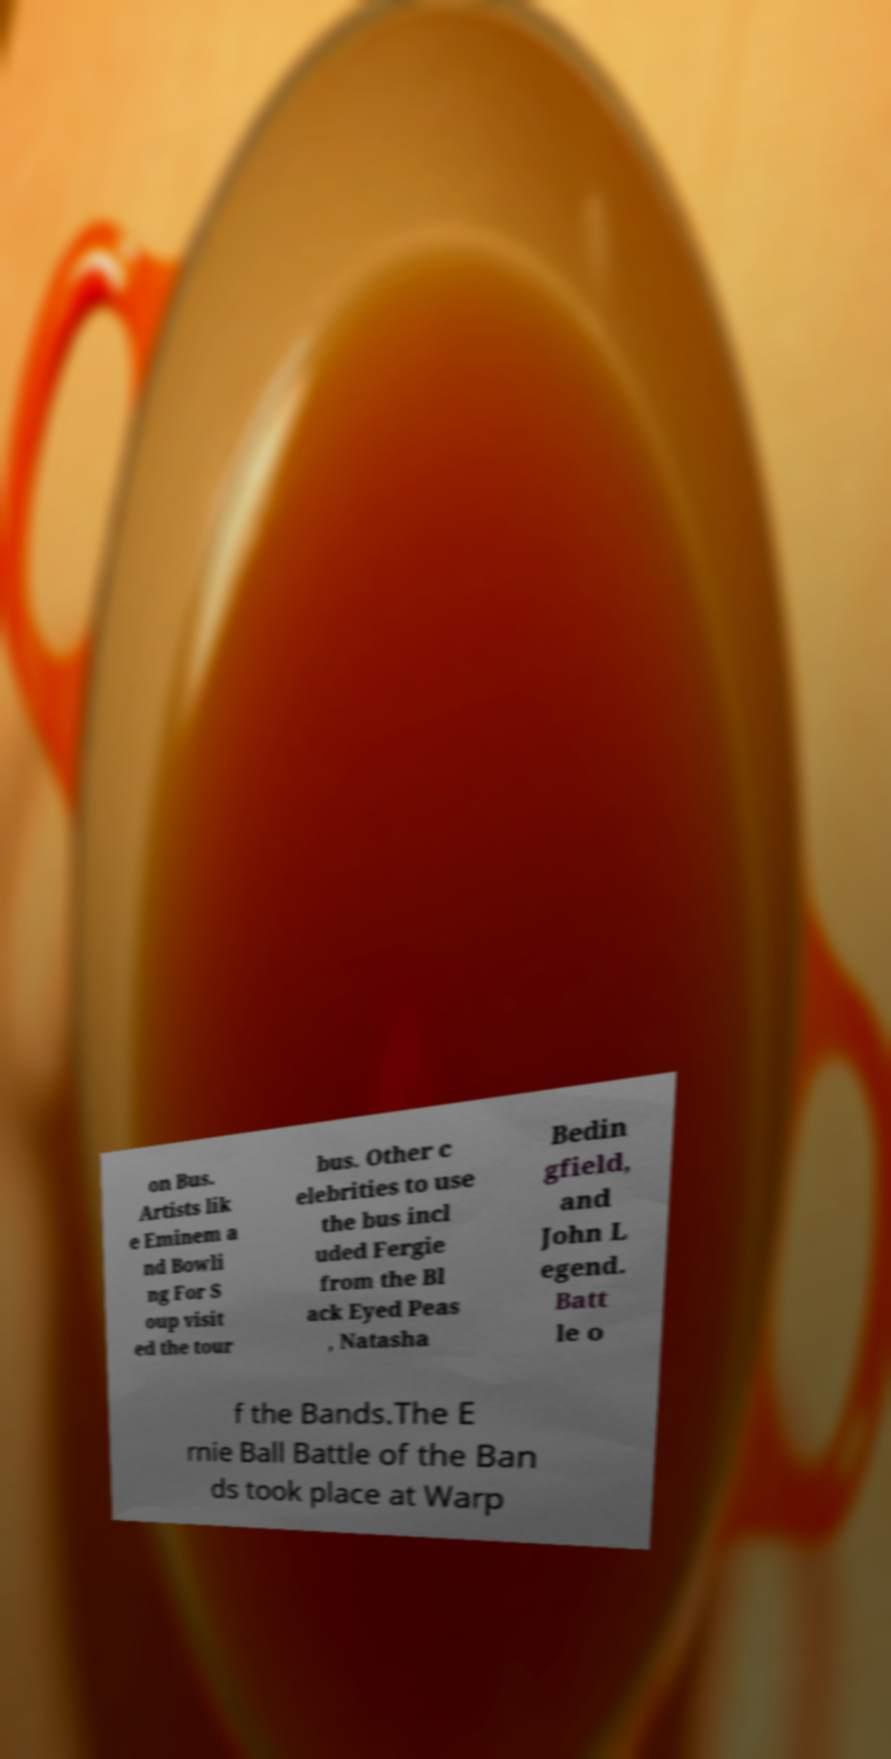Could you assist in decoding the text presented in this image and type it out clearly? on Bus. Artists lik e Eminem a nd Bowli ng For S oup visit ed the tour bus. Other c elebrities to use the bus incl uded Fergie from the Bl ack Eyed Peas , Natasha Bedin gfield, and John L egend. Batt le o f the Bands.The E rnie Ball Battle of the Ban ds took place at Warp 